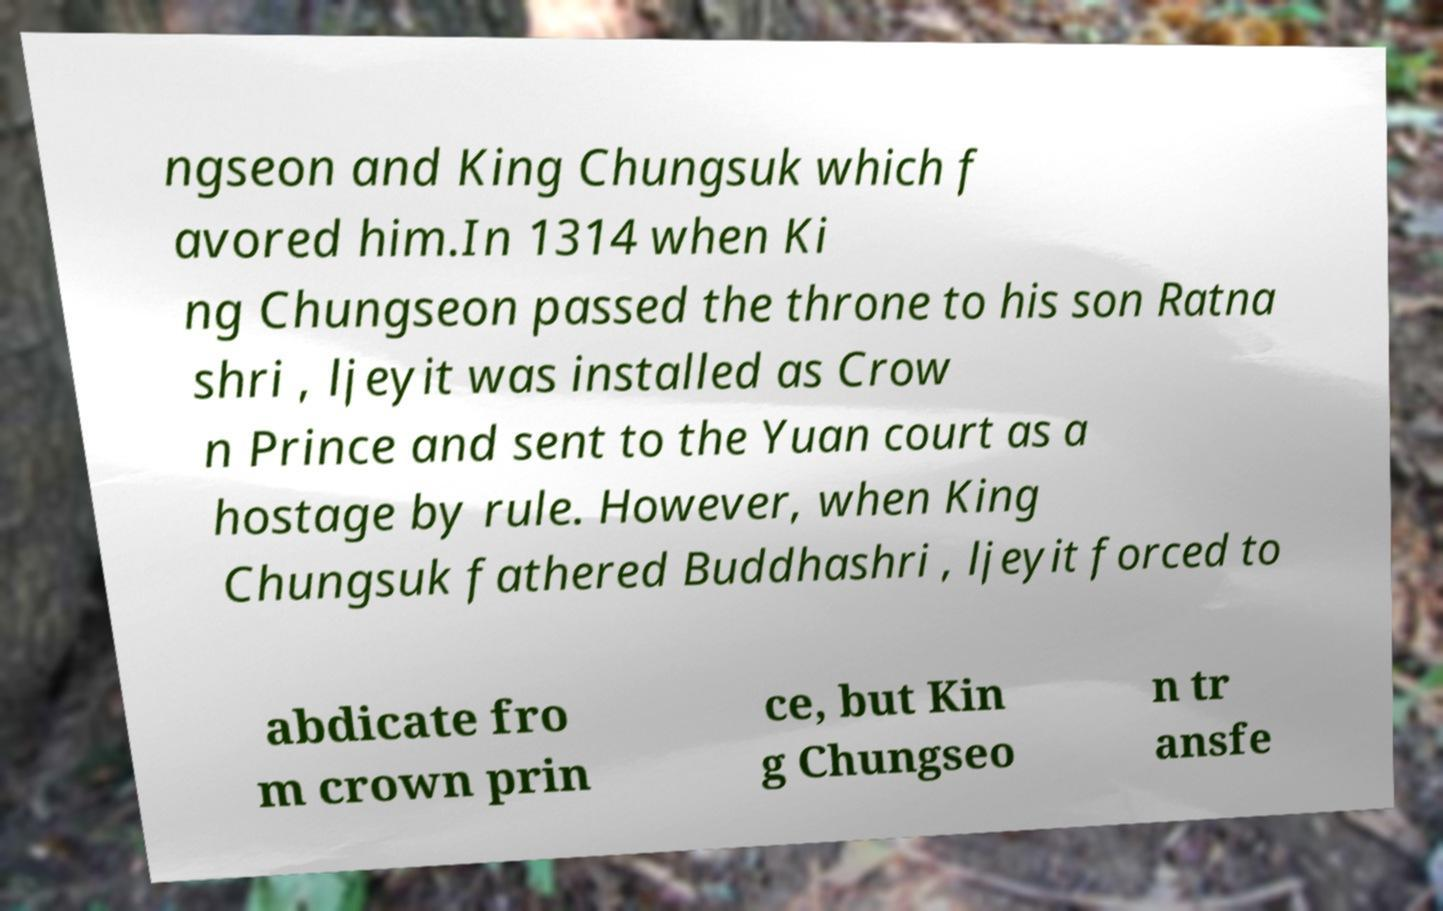There's text embedded in this image that I need extracted. Can you transcribe it verbatim? ngseon and King Chungsuk which f avored him.In 1314 when Ki ng Chungseon passed the throne to his son Ratna shri , ljeyit was installed as Crow n Prince and sent to the Yuan court as a hostage by rule. However, when King Chungsuk fathered Buddhashri , ljeyit forced to abdicate fro m crown prin ce, but Kin g Chungseo n tr ansfe 